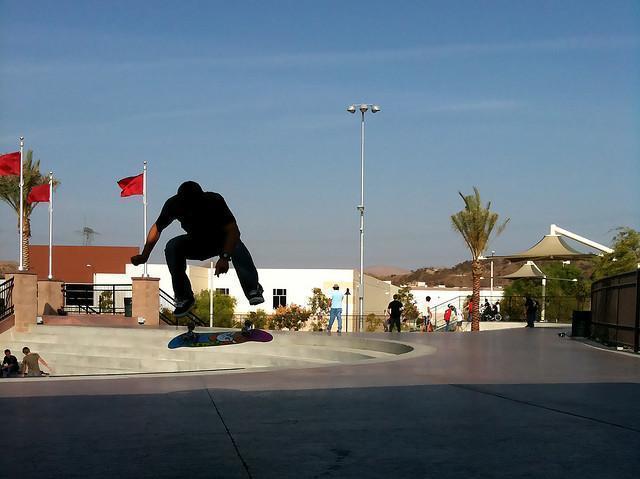What action is he taking with the board?
Select the accurate response from the four choices given to answer the question.
Options: Bounce, throw, kick, flip. Flip. 